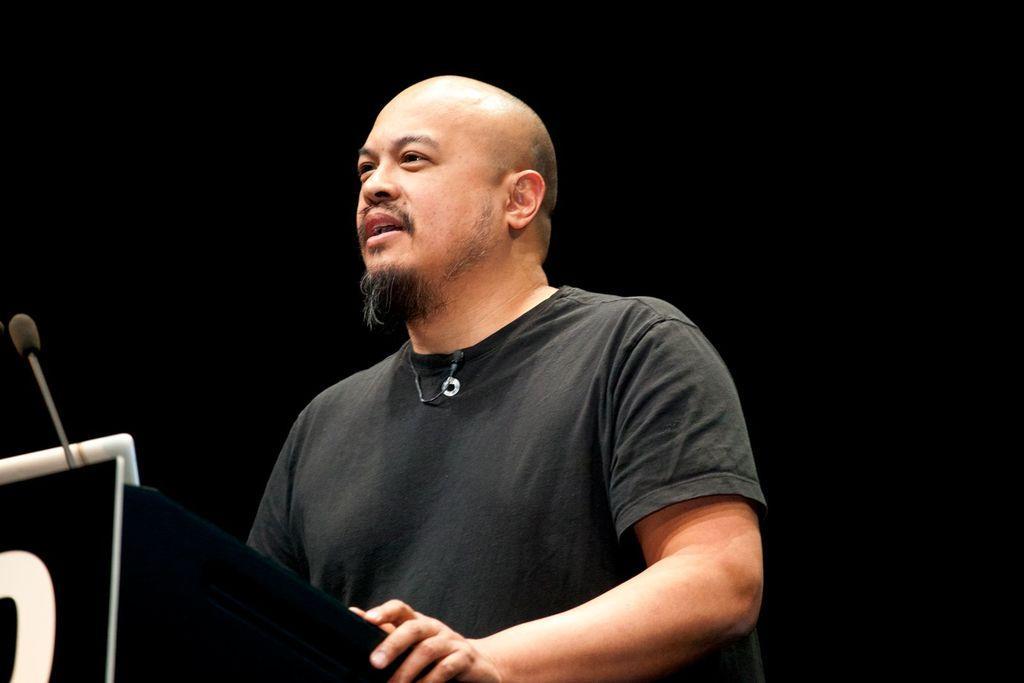Describe this image in one or two sentences. In this picture we can see a man, podium, mic and in the background it is dark. 